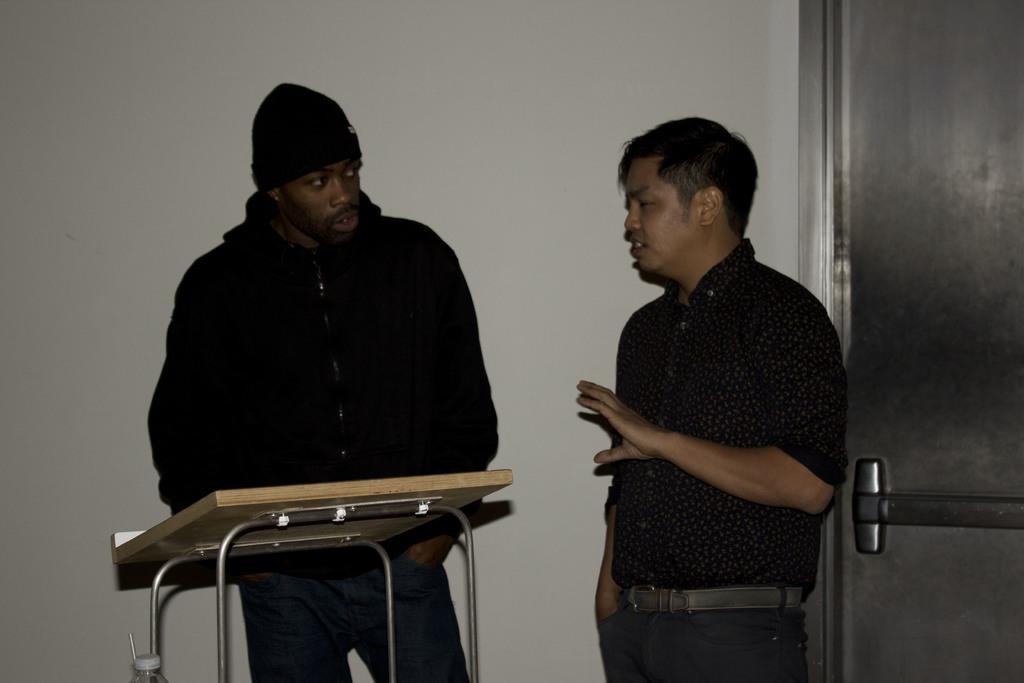Describe this image in one or two sentences. In this image there are two persons, a table, a bottle, a door and the wall. 